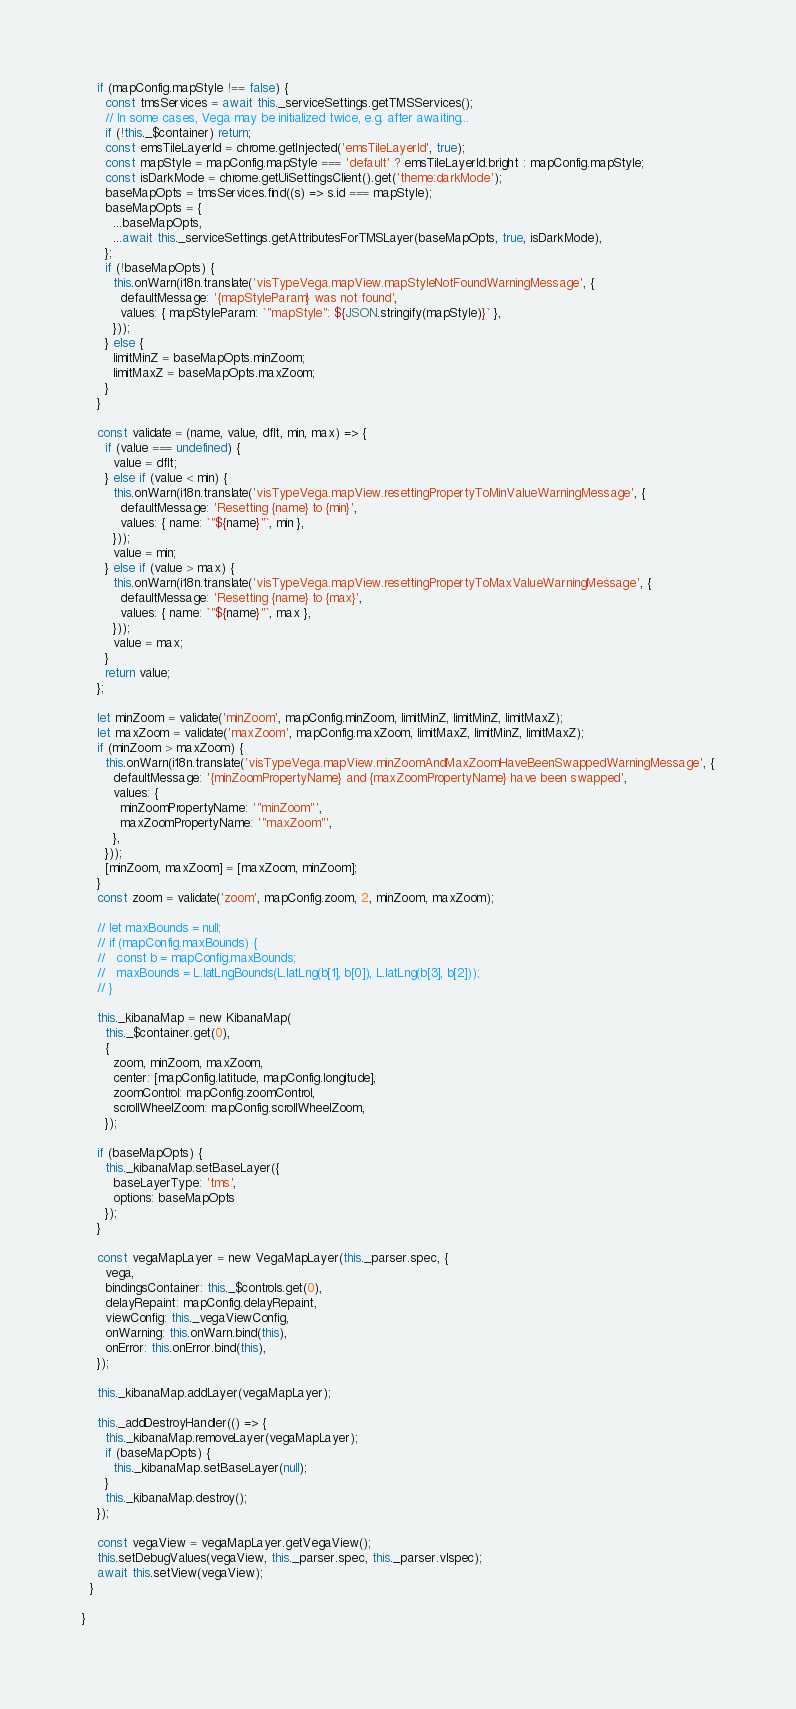<code> <loc_0><loc_0><loc_500><loc_500><_JavaScript_>
    if (mapConfig.mapStyle !== false) {
      const tmsServices = await this._serviceSettings.getTMSServices();
      // In some cases, Vega may be initialized twice, e.g. after awaiting...
      if (!this._$container) return;
      const emsTileLayerId = chrome.getInjected('emsTileLayerId', true);
      const mapStyle = mapConfig.mapStyle === 'default' ? emsTileLayerId.bright : mapConfig.mapStyle;
      const isDarkMode = chrome.getUiSettingsClient().get('theme:darkMode');
      baseMapOpts = tmsServices.find((s) => s.id === mapStyle);
      baseMapOpts = {
        ...baseMapOpts,
        ...await this._serviceSettings.getAttributesForTMSLayer(baseMapOpts, true, isDarkMode),
      };
      if (!baseMapOpts) {
        this.onWarn(i18n.translate('visTypeVega.mapView.mapStyleNotFoundWarningMessage', {
          defaultMessage: '{mapStyleParam} was not found',
          values: { mapStyleParam: `"mapStyle": ${JSON.stringify(mapStyle)}` },
        }));
      } else {
        limitMinZ = baseMapOpts.minZoom;
        limitMaxZ = baseMapOpts.maxZoom;
      }
    }

    const validate = (name, value, dflt, min, max) => {
      if (value === undefined) {
        value = dflt;
      } else if (value < min) {
        this.onWarn(i18n.translate('visTypeVega.mapView.resettingPropertyToMinValueWarningMessage', {
          defaultMessage: 'Resetting {name} to {min}',
          values: { name: `"${name}"`, min },
        }));
        value = min;
      } else if (value > max) {
        this.onWarn(i18n.translate('visTypeVega.mapView.resettingPropertyToMaxValueWarningMessage', {
          defaultMessage: 'Resetting {name} to {max}',
          values: { name: `"${name}"`, max },
        }));
        value = max;
      }
      return value;
    };

    let minZoom = validate('minZoom', mapConfig.minZoom, limitMinZ, limitMinZ, limitMaxZ);
    let maxZoom = validate('maxZoom', mapConfig.maxZoom, limitMaxZ, limitMinZ, limitMaxZ);
    if (minZoom > maxZoom) {
      this.onWarn(i18n.translate('visTypeVega.mapView.minZoomAndMaxZoomHaveBeenSwappedWarningMessage', {
        defaultMessage: '{minZoomPropertyName} and {maxZoomPropertyName} have been swapped',
        values: {
          minZoomPropertyName: '"minZoom"',
          maxZoomPropertyName: '"maxZoom"',
        },
      }));
      [minZoom, maxZoom] = [maxZoom, minZoom];
    }
    const zoom = validate('zoom', mapConfig.zoom, 2, minZoom, maxZoom);

    // let maxBounds = null;
    // if (mapConfig.maxBounds) {
    //   const b = mapConfig.maxBounds;
    //   maxBounds = L.latLngBounds(L.latLng(b[1], b[0]), L.latLng(b[3], b[2]));
    // }

    this._kibanaMap = new KibanaMap(
      this._$container.get(0),
      {
        zoom, minZoom, maxZoom,
        center: [mapConfig.latitude, mapConfig.longitude],
        zoomControl: mapConfig.zoomControl,
        scrollWheelZoom: mapConfig.scrollWheelZoom,
      });

    if (baseMapOpts) {
      this._kibanaMap.setBaseLayer({
        baseLayerType: 'tms',
        options: baseMapOpts
      });
    }

    const vegaMapLayer = new VegaMapLayer(this._parser.spec, {
      vega,
      bindingsContainer: this._$controls.get(0),
      delayRepaint: mapConfig.delayRepaint,
      viewConfig: this._vegaViewConfig,
      onWarning: this.onWarn.bind(this),
      onError: this.onError.bind(this),
    });

    this._kibanaMap.addLayer(vegaMapLayer);

    this._addDestroyHandler(() => {
      this._kibanaMap.removeLayer(vegaMapLayer);
      if (baseMapOpts) {
        this._kibanaMap.setBaseLayer(null);
      }
      this._kibanaMap.destroy();
    });

    const vegaView = vegaMapLayer.getVegaView();
    this.setDebugValues(vegaView, this._parser.spec, this._parser.vlspec);
    await this.setView(vegaView);
  }

}
</code> 